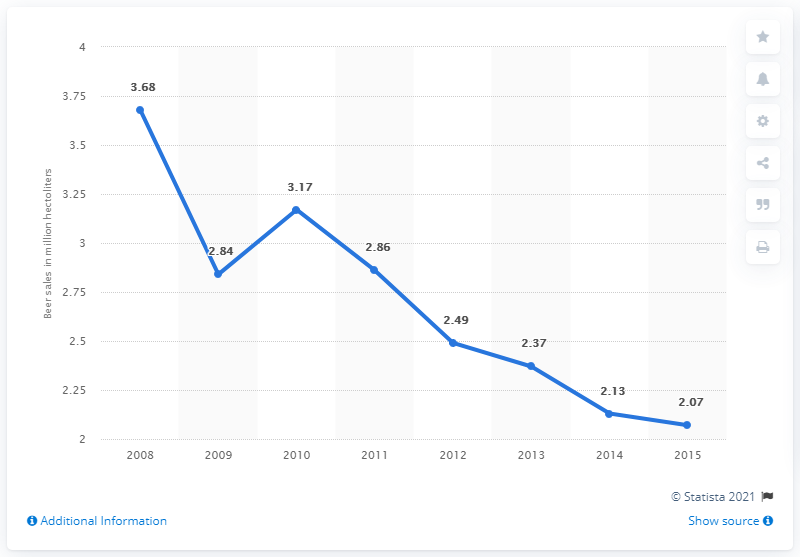Indicate a few pertinent items in this graphic. The export reached its peak in 2008. In 2012, Canada exported 2.49 hectoliters of beer to the United States. The export has been above 2.5 for how many years? Four... 